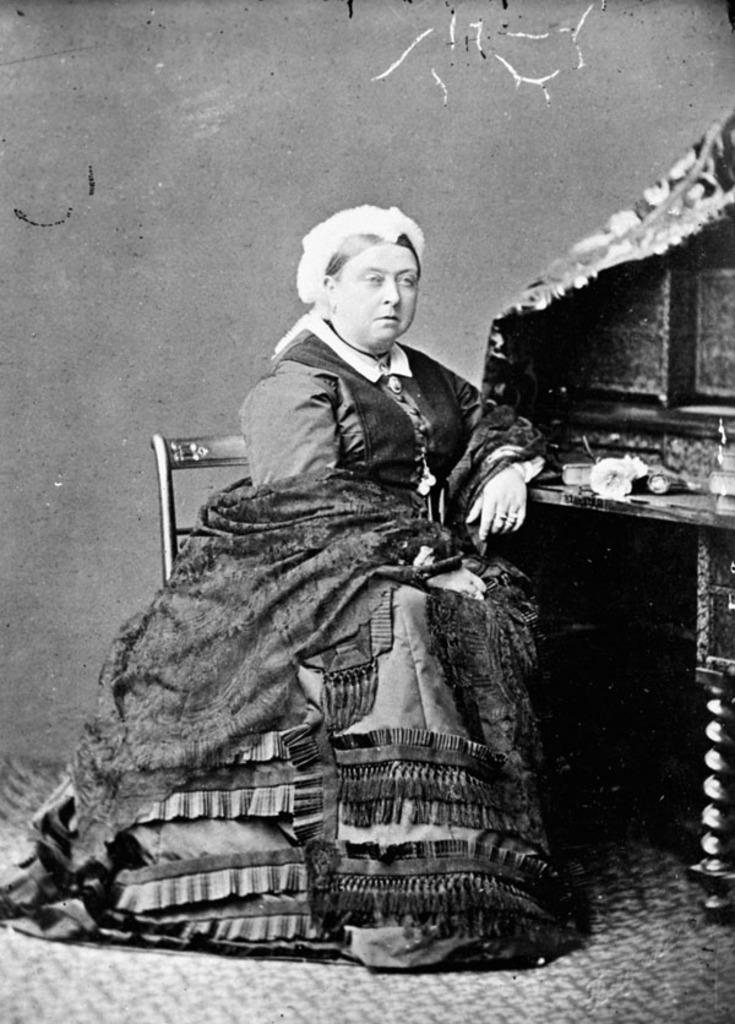What is the person in the image doing? The person is sitting on a chair in the image. Where is the chair located? The chair is on the ground. What other piece of furniture is present in the image? There is a table in the image. What can be seen on the table? There are objects on the table. What can be seen in the background of the image? There is a wall visible in the background of the image. What type of journey is the person embarking on in the image? There is no indication of a journey in the image; it simply shows a person sitting on a chair. 